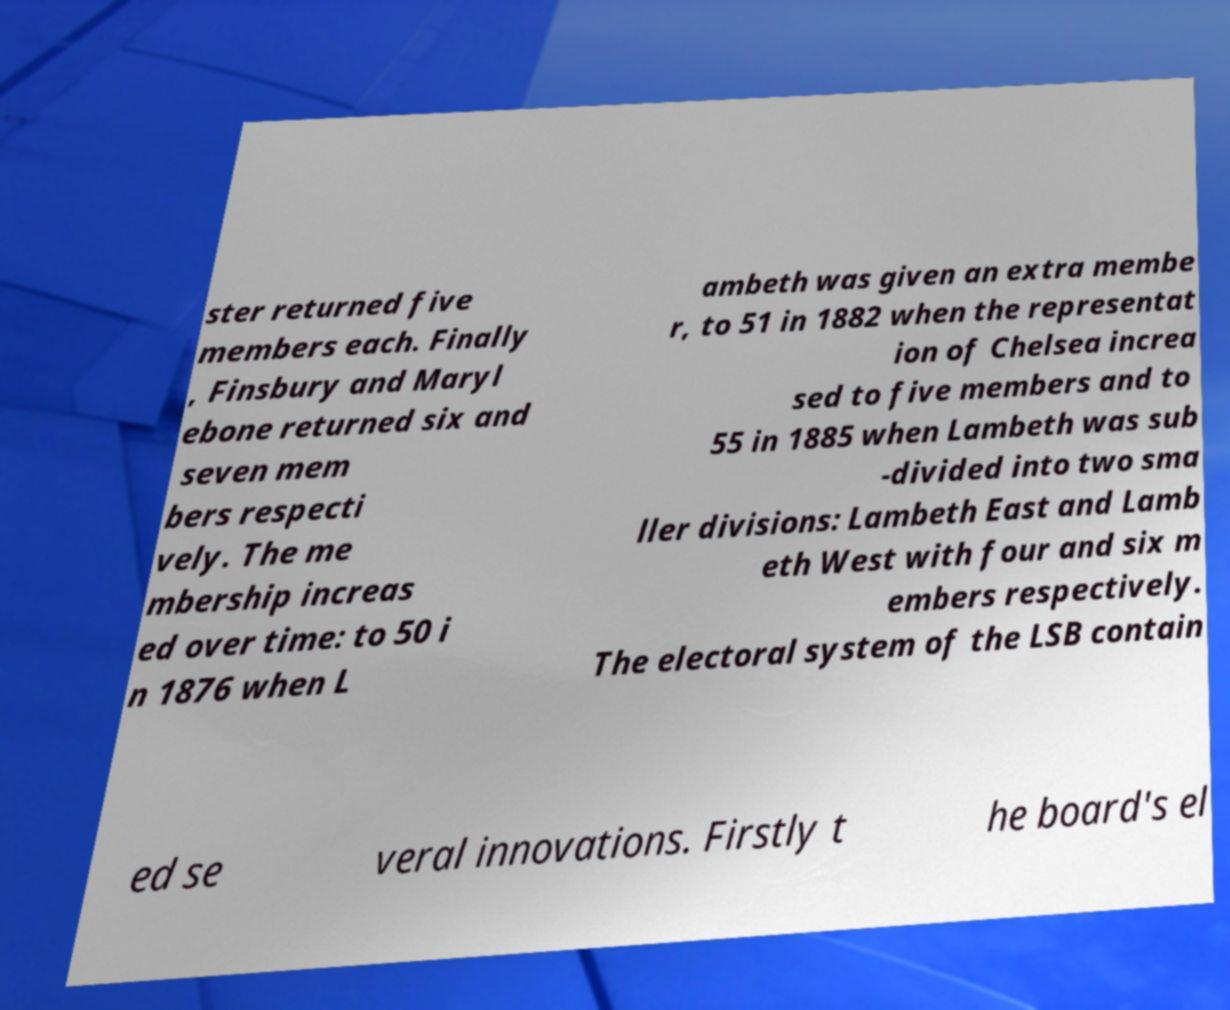Can you read and provide the text displayed in the image?This photo seems to have some interesting text. Can you extract and type it out for me? ster returned five members each. Finally , Finsbury and Maryl ebone returned six and seven mem bers respecti vely. The me mbership increas ed over time: to 50 i n 1876 when L ambeth was given an extra membe r, to 51 in 1882 when the representat ion of Chelsea increa sed to five members and to 55 in 1885 when Lambeth was sub -divided into two sma ller divisions: Lambeth East and Lamb eth West with four and six m embers respectively. The electoral system of the LSB contain ed se veral innovations. Firstly t he board's el 